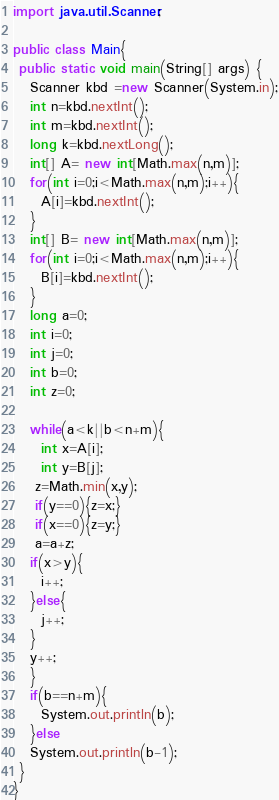Convert code to text. <code><loc_0><loc_0><loc_500><loc_500><_Java_>import java.util.Scanner;

public class Main{
 public static void main(String[] args) {
   Scanner kbd =new Scanner(System.in);
   int n=kbd.nextInt();
   int m=kbd.nextInt();
   long k=kbd.nextLong();
   int[] A= new int[Math.max(n,m)];
   for(int i=0;i<Math.max(n,m);i++){
     A[i]=kbd.nextInt();
   }
   int[] B= new int[Math.max(n,m)];
   for(int i=0;i<Math.max(n,m);i++){
     B[i]=kbd.nextInt();
   }
   long a=0;
   int i=0;
   int j=0;
   int b=0;
   int z=0;

   while(a<k||b<n+m){
     int x=A[i];
     int y=B[j];
    z=Math.min(x,y);
    if(y==0){z=x;}
    if(x==0){z=y;}
    a=a+z;
   if(x>y){
     i++;
   }else{
     j++;
   }
   y++;
   }
   if(b==n+m){
     System.out.println(b);
   }else
   System.out.println(b-1);
 }
}</code> 